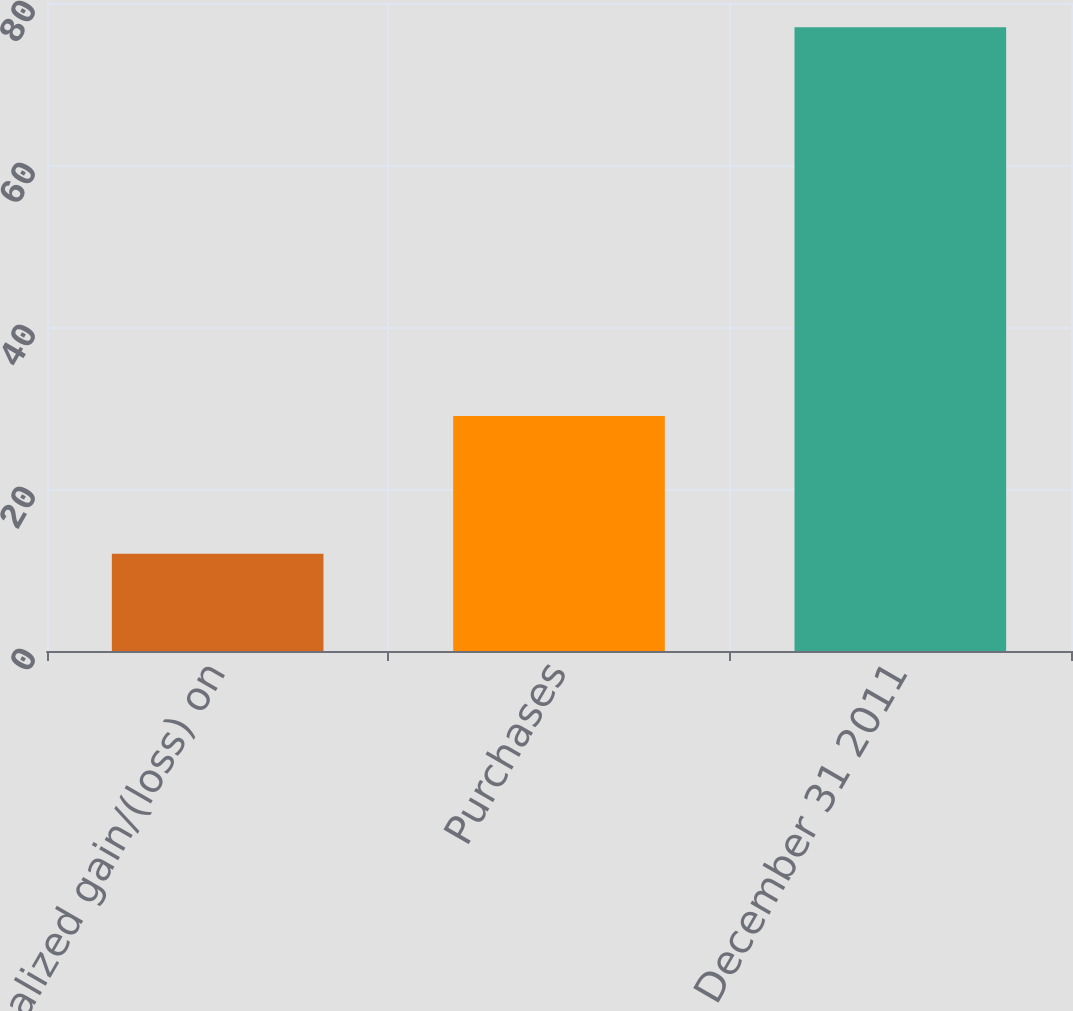<chart> <loc_0><loc_0><loc_500><loc_500><bar_chart><fcel>Net unrealized gain/(loss) on<fcel>Purchases<fcel>December 31 2011<nl><fcel>12<fcel>29<fcel>77<nl></chart> 